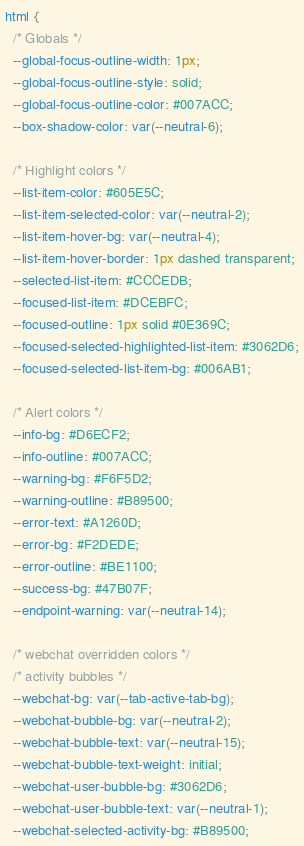Convert code to text. <code><loc_0><loc_0><loc_500><loc_500><_CSS_>html {
  /* Globals */
  --global-focus-outline-width: 1px;
  --global-focus-outline-style: solid;
  --global-focus-outline-color: #007ACC;
  --box-shadow-color: var(--neutral-6);

  /* Highlight colors */
  --list-item-color: #605E5C;
  --list-item-selected-color: var(--neutral-2);
  --list-item-hover-bg: var(--neutral-4);
  --list-item-hover-border: 1px dashed transparent;
  --selected-list-item: #CCCEDB;
  --focused-list-item: #DCEBFC;
  --focused-outline: 1px solid #0E369C;
  --focused-selected-highlighted-list-item: #3062D6;
  --focused-selected-list-item-bg: #006AB1;

  /* Alert colors */
  --info-bg: #D6ECF2;
  --info-outline: #007ACC;
  --warning-bg: #F6F5D2;
  --warning-outline: #B89500;
  --error-text: #A1260D;
  --error-bg: #F2DEDE;
  --error-outline: #BE1100;
  --success-bg: #47B07F;
  --endpoint-warning: var(--neutral-14);

  /* webchat overridden colors */
  /* activity bubbles */
  --webchat-bg: var(--tab-active-tab-bg);
  --webchat-bubble-bg: var(--neutral-2);
  --webchat-bubble-text: var(--neutral-15);
  --webchat-bubble-text-weight: initial;
  --webchat-user-bubble-bg: #3062D6;
  --webchat-user-bubble-text: var(--neutral-1);
  --webchat-selected-activity-bg: #B89500;</code> 